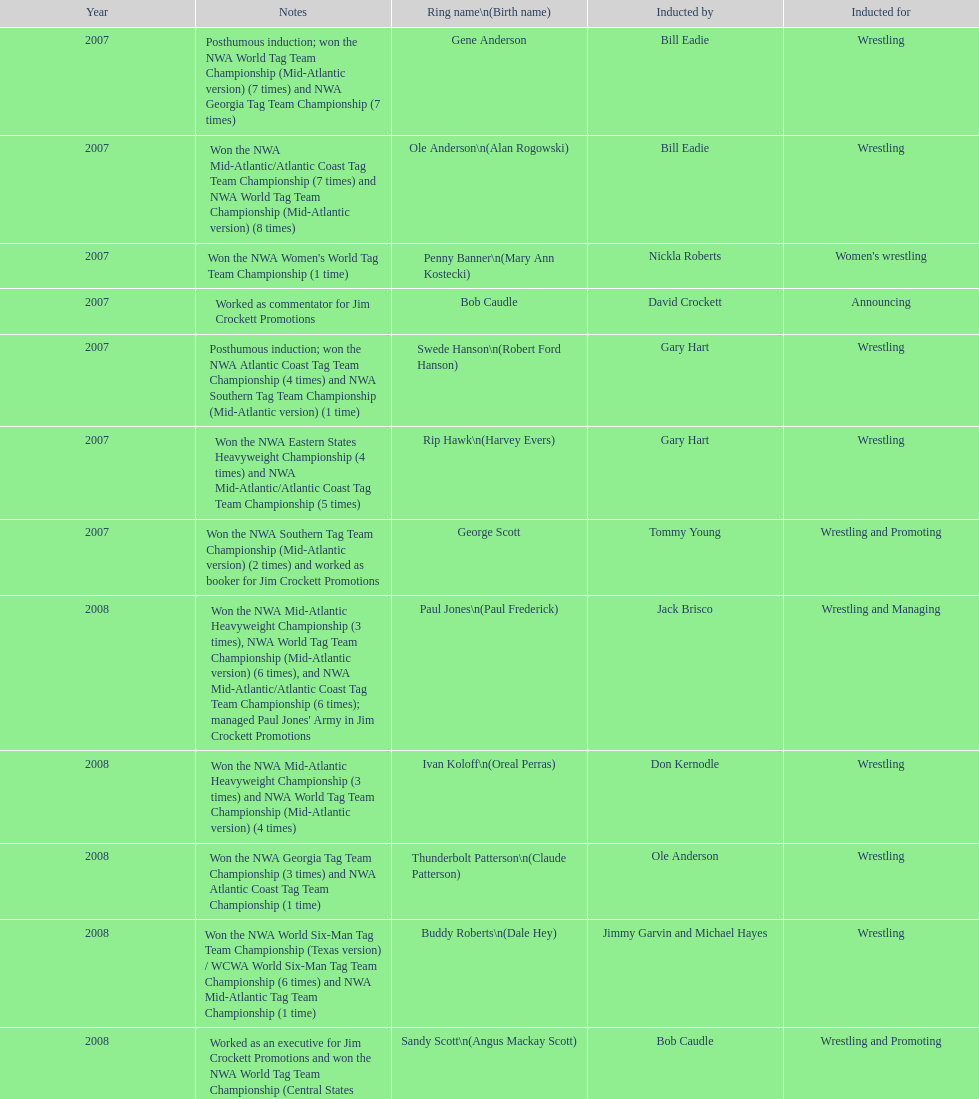Bob caudle was an announcer, who was the other one? Lance Russell. 